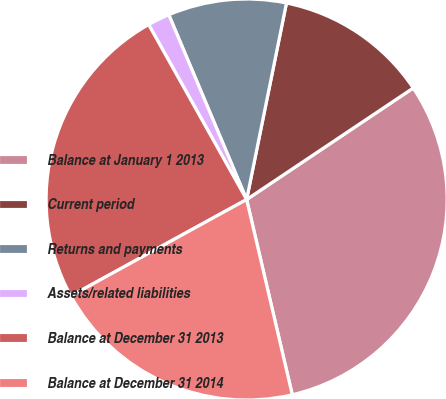Convert chart. <chart><loc_0><loc_0><loc_500><loc_500><pie_chart><fcel>Balance at January 1 2013<fcel>Current period<fcel>Returns and payments<fcel>Assets/related liabilities<fcel>Balance at December 31 2013<fcel>Balance at December 31 2014<nl><fcel>30.73%<fcel>12.43%<fcel>9.53%<fcel>1.78%<fcel>24.86%<fcel>20.67%<nl></chart> 